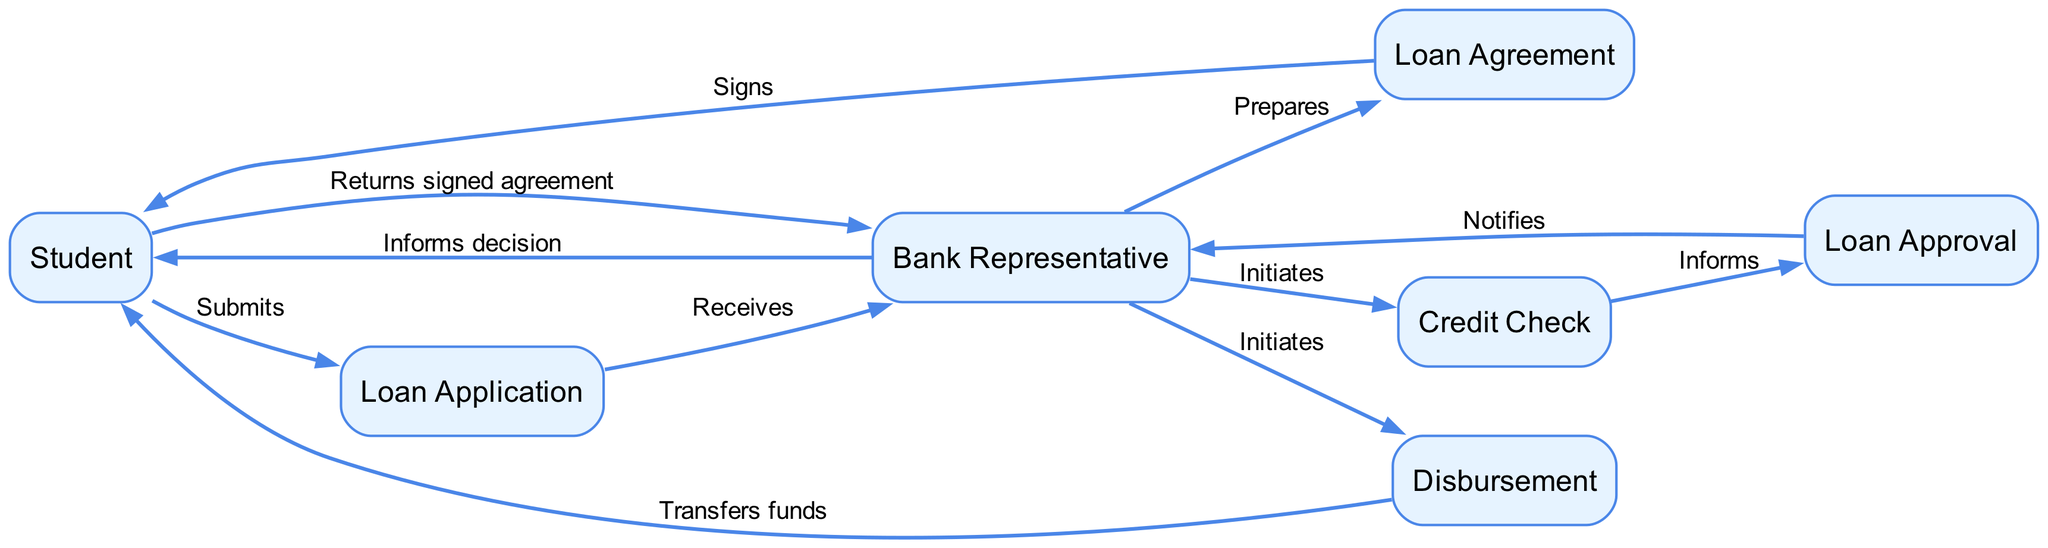What is the first action taken by the Student? The diagram shows that the first action the Student takes is to submit the Loan Application. This is indicated by the directed edge from the Student node to the Loan Application node labeled 'Submits'.
Answer: Submits How many interactions are there between the Bank Representative and the Student? By counting the directed edges between these two nodes, there are two interactions: one where the Bank Representative informs the Student of the decision and another where the Student returns the signed agreement to the Bank Representative.
Answer: Two Which node represents the transfer of funds? The Disbursement node represents the transfer of loan funds to the Student's account. This is noted by the directed edge from the Disbursement node to the Student node labeled 'Transfers funds'.
Answer: Disbursement What does the Bank Representative do after receiving the Loan Application? After receiving the Loan Application, the Bank Representative initiates a Credit Check. This is shown by the directed edge that connects the Loan Application node to the Credit Check node, labeled 'Initiates'.
Answer: Initiates What is the final step in the loan application process? The final step in the loan application process is the transfer of funds to the Student. This is indicated by the last directed edge in the sequence diagram leading from the Disbursement node to the Student node labeled 'Transfers funds'.
Answer: Transfers funds Which document does the Student sign? The Loan Agreement is the document that the Student signs, as indicated by the directed edge connecting the Loan Agreement node to the Student node labeled 'Signs'.
Answer: Loan Agreement What is evaluated during the Credit Check? The Credit Check evaluates the Student's creditworthiness. This is implied by the fact that the Credit Check node is followed by the Loan Approval node, suggesting that the evaluation is part of the approval process.
Answer: Creditworthiness How many nodes are there in total in the diagram? There are seven distinct nodes in the diagram: Student, Bank Representative, Loan Application, Credit Check, Loan Approval, Loan Agreement, and Disbursement. Counting each of these gives us a total of seven nodes.
Answer: Seven 